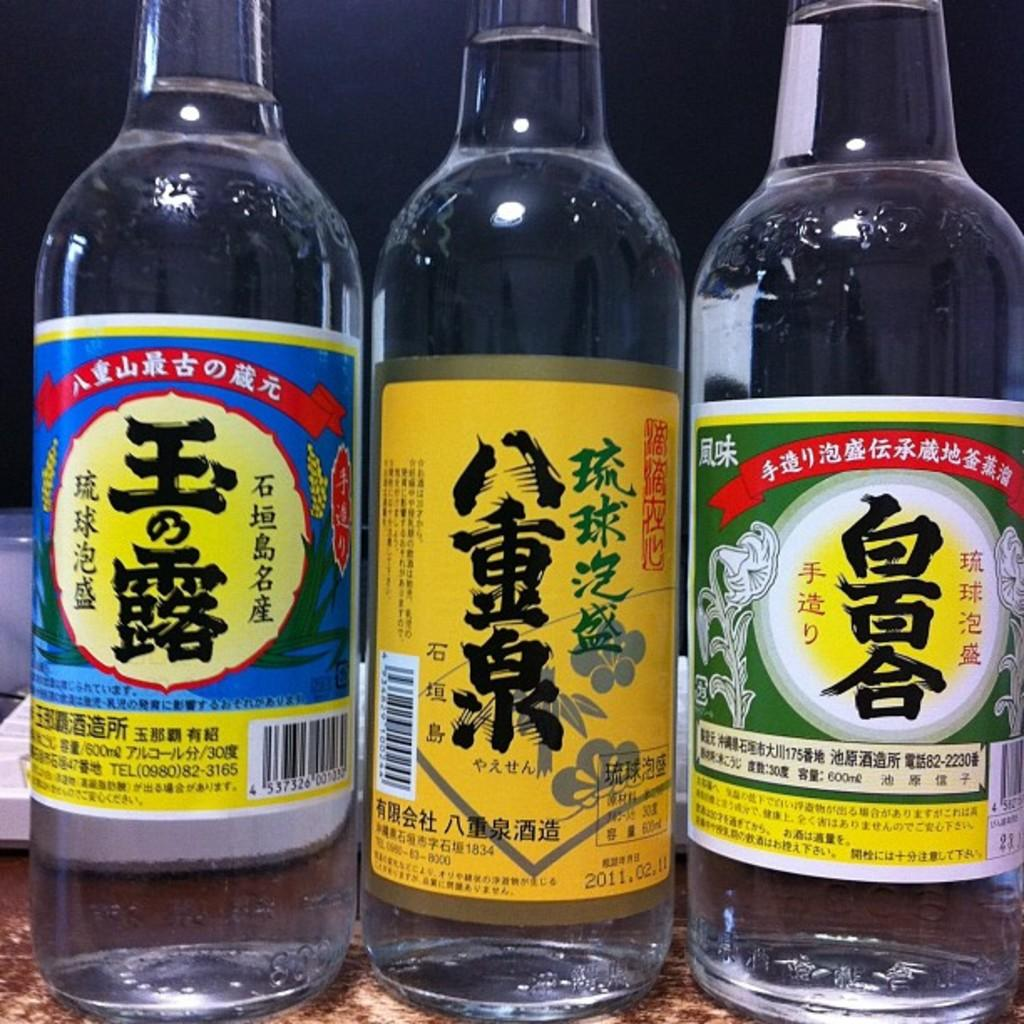<image>
Give a short and clear explanation of the subsequent image. A bottle with an orange label has 2011.02.11 written near the bottom. 